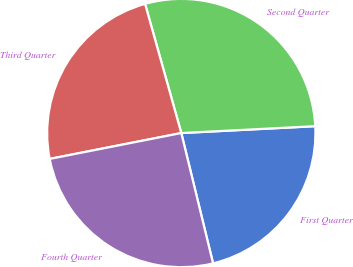<chart> <loc_0><loc_0><loc_500><loc_500><pie_chart><fcel>First Quarter<fcel>Second Quarter<fcel>Third Quarter<fcel>Fourth Quarter<nl><fcel>22.01%<fcel>28.54%<fcel>23.74%<fcel>25.72%<nl></chart> 